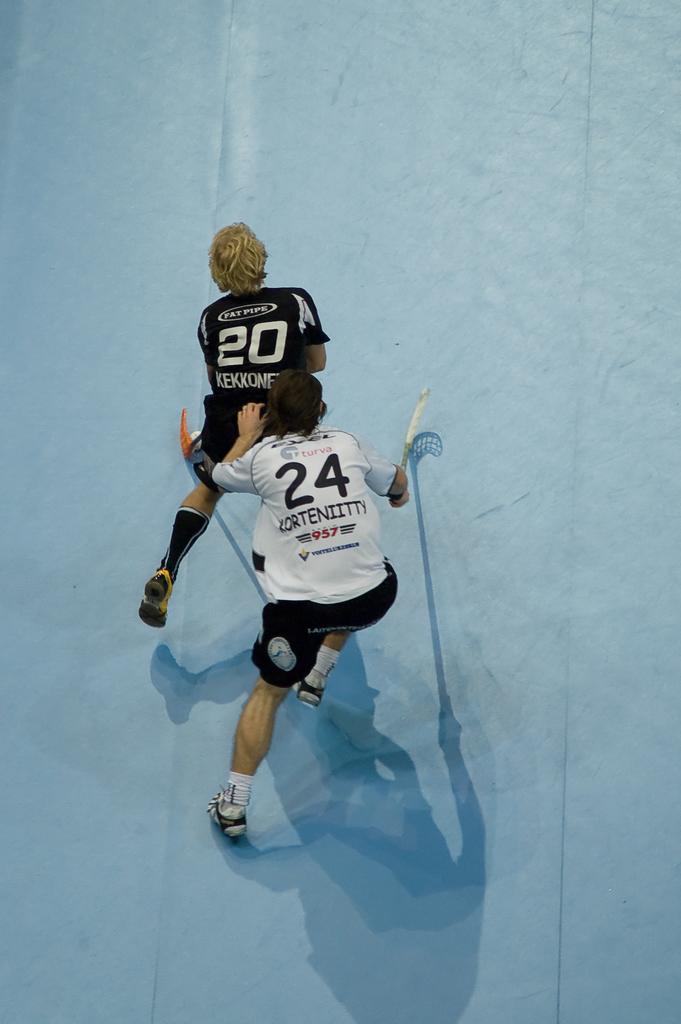What are the players numbers that are pictured?
Provide a succinct answer. 20 24. 